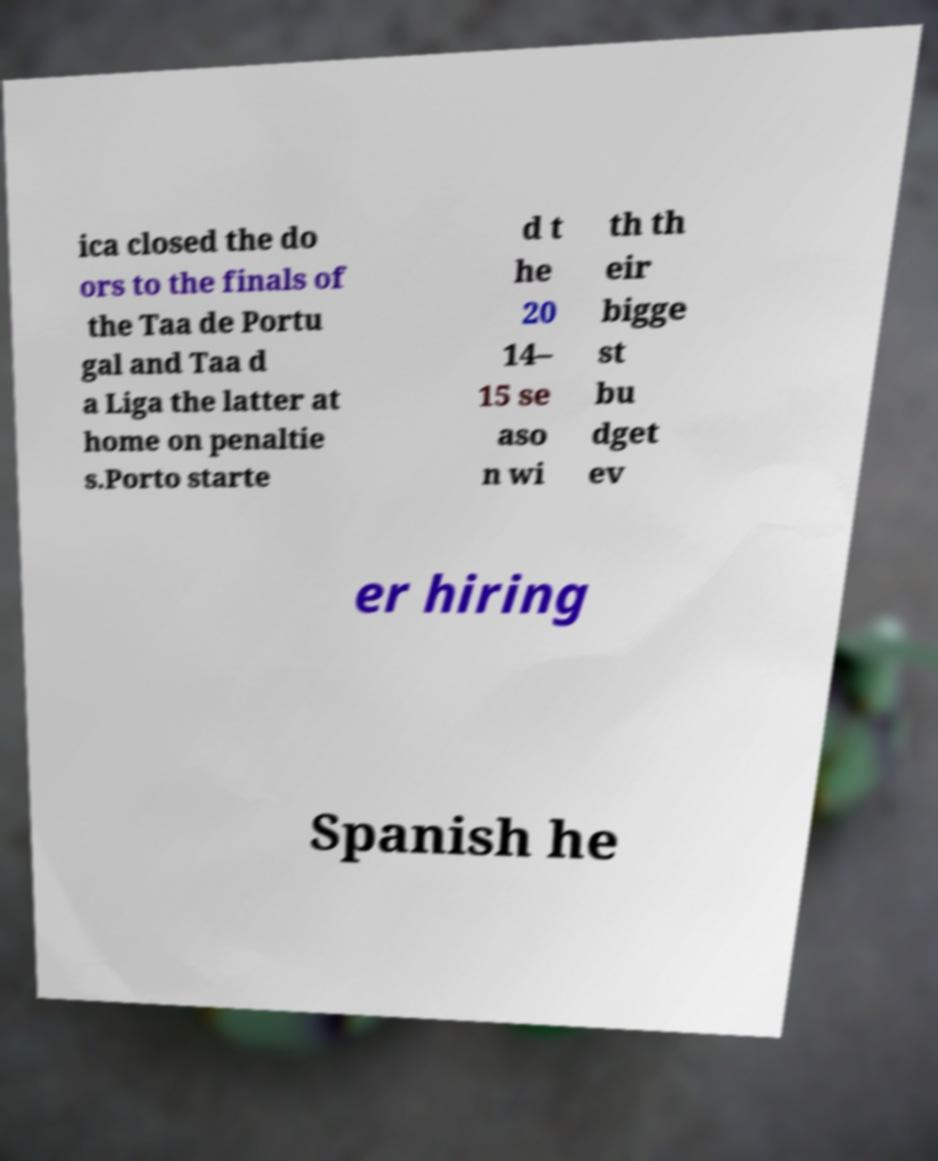Could you extract and type out the text from this image? ica closed the do ors to the finals of the Taa de Portu gal and Taa d a Liga the latter at home on penaltie s.Porto starte d t he 20 14– 15 se aso n wi th th eir bigge st bu dget ev er hiring Spanish he 